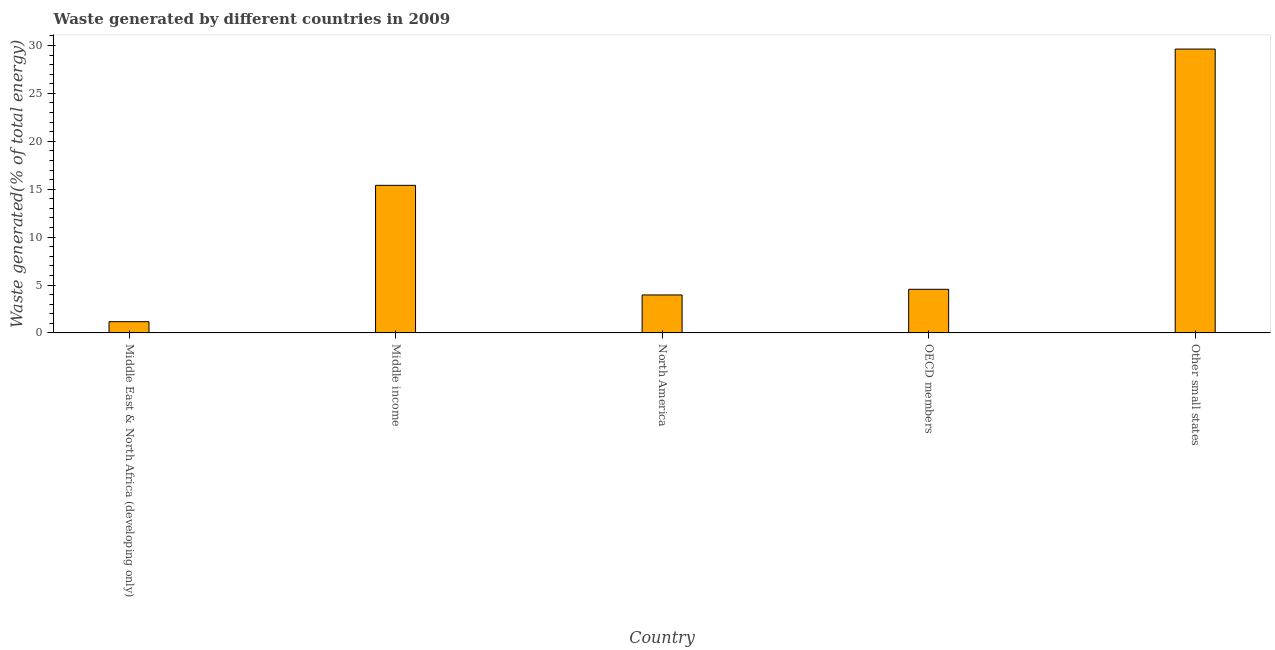Does the graph contain any zero values?
Your response must be concise. No. What is the title of the graph?
Your answer should be compact. Waste generated by different countries in 2009. What is the label or title of the X-axis?
Your response must be concise. Country. What is the label or title of the Y-axis?
Give a very brief answer. Waste generated(% of total energy). What is the amount of waste generated in OECD members?
Provide a short and direct response. 4.56. Across all countries, what is the maximum amount of waste generated?
Your answer should be very brief. 29.63. Across all countries, what is the minimum amount of waste generated?
Your answer should be very brief. 1.18. In which country was the amount of waste generated maximum?
Offer a terse response. Other small states. In which country was the amount of waste generated minimum?
Your answer should be very brief. Middle East & North Africa (developing only). What is the sum of the amount of waste generated?
Your answer should be compact. 54.73. What is the difference between the amount of waste generated in Middle income and North America?
Provide a succinct answer. 11.44. What is the average amount of waste generated per country?
Offer a very short reply. 10.95. What is the median amount of waste generated?
Keep it short and to the point. 4.56. What is the ratio of the amount of waste generated in Middle East & North Africa (developing only) to that in Middle income?
Your answer should be very brief. 0.08. Is the amount of waste generated in Middle East & North Africa (developing only) less than that in Middle income?
Your answer should be very brief. Yes. Is the difference between the amount of waste generated in OECD members and Other small states greater than the difference between any two countries?
Provide a short and direct response. No. What is the difference between the highest and the second highest amount of waste generated?
Make the answer very short. 14.22. Is the sum of the amount of waste generated in Middle East & North Africa (developing only) and Other small states greater than the maximum amount of waste generated across all countries?
Your answer should be compact. Yes. What is the difference between the highest and the lowest amount of waste generated?
Provide a succinct answer. 28.45. Are all the bars in the graph horizontal?
Make the answer very short. No. What is the difference between two consecutive major ticks on the Y-axis?
Make the answer very short. 5. What is the Waste generated(% of total energy) of Middle East & North Africa (developing only)?
Your answer should be very brief. 1.18. What is the Waste generated(% of total energy) in Middle income?
Your response must be concise. 15.41. What is the Waste generated(% of total energy) in North America?
Give a very brief answer. 3.96. What is the Waste generated(% of total energy) in OECD members?
Your answer should be compact. 4.56. What is the Waste generated(% of total energy) in Other small states?
Your answer should be compact. 29.63. What is the difference between the Waste generated(% of total energy) in Middle East & North Africa (developing only) and Middle income?
Keep it short and to the point. -14.23. What is the difference between the Waste generated(% of total energy) in Middle East & North Africa (developing only) and North America?
Offer a very short reply. -2.79. What is the difference between the Waste generated(% of total energy) in Middle East & North Africa (developing only) and OECD members?
Provide a short and direct response. -3.38. What is the difference between the Waste generated(% of total energy) in Middle East & North Africa (developing only) and Other small states?
Your response must be concise. -28.45. What is the difference between the Waste generated(% of total energy) in Middle income and North America?
Make the answer very short. 11.44. What is the difference between the Waste generated(% of total energy) in Middle income and OECD members?
Provide a short and direct response. 10.85. What is the difference between the Waste generated(% of total energy) in Middle income and Other small states?
Your response must be concise. -14.22. What is the difference between the Waste generated(% of total energy) in North America and OECD members?
Your response must be concise. -0.59. What is the difference between the Waste generated(% of total energy) in North America and Other small states?
Offer a very short reply. -25.67. What is the difference between the Waste generated(% of total energy) in OECD members and Other small states?
Ensure brevity in your answer.  -25.07. What is the ratio of the Waste generated(% of total energy) in Middle East & North Africa (developing only) to that in Middle income?
Your answer should be compact. 0.08. What is the ratio of the Waste generated(% of total energy) in Middle East & North Africa (developing only) to that in North America?
Give a very brief answer. 0.3. What is the ratio of the Waste generated(% of total energy) in Middle East & North Africa (developing only) to that in OECD members?
Ensure brevity in your answer.  0.26. What is the ratio of the Waste generated(% of total energy) in Middle income to that in North America?
Provide a short and direct response. 3.89. What is the ratio of the Waste generated(% of total energy) in Middle income to that in OECD members?
Give a very brief answer. 3.38. What is the ratio of the Waste generated(% of total energy) in Middle income to that in Other small states?
Your answer should be very brief. 0.52. What is the ratio of the Waste generated(% of total energy) in North America to that in OECD members?
Give a very brief answer. 0.87. What is the ratio of the Waste generated(% of total energy) in North America to that in Other small states?
Your response must be concise. 0.13. What is the ratio of the Waste generated(% of total energy) in OECD members to that in Other small states?
Your answer should be compact. 0.15. 